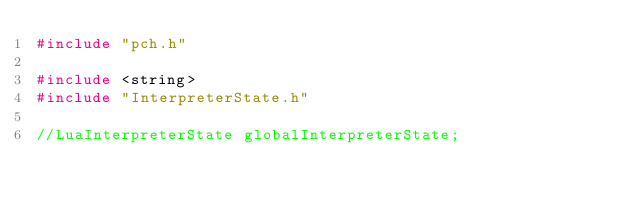Convert code to text. <code><loc_0><loc_0><loc_500><loc_500><_C++_>#include "pch.h"

#include <string>
#include "InterpreterState.h"
	
//LuaInterpreterState globalInterpreterState;
</code> 